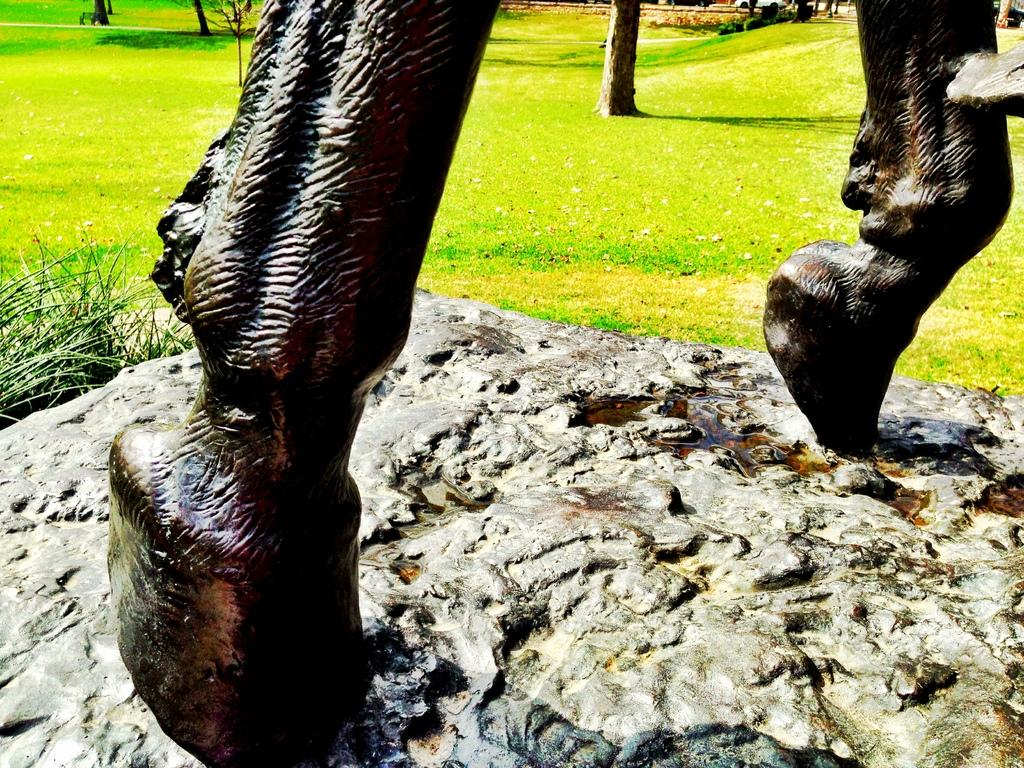What is the main subject of the image? There is a statue of an animal in the image. What type of vegetation is present on the left side of the image? There is grass on the left side of the image. How many people are attending the feast in the image? There is no feast or people present in the image; it features a statue of an animal and grass. 